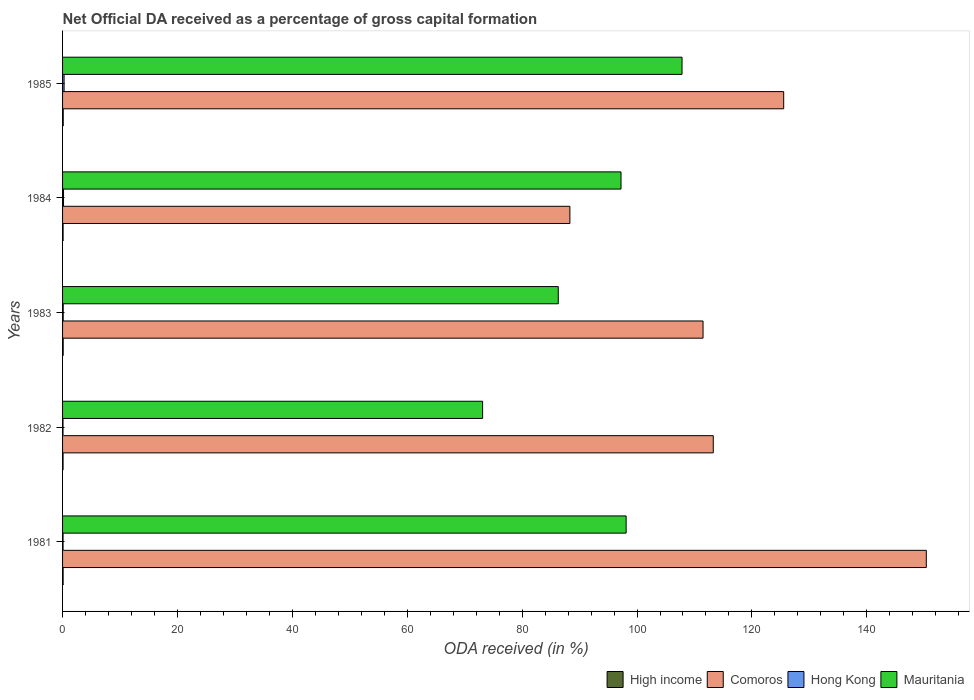How many groups of bars are there?
Provide a succinct answer. 5. Are the number of bars on each tick of the Y-axis equal?
Provide a succinct answer. Yes. What is the label of the 1st group of bars from the top?
Ensure brevity in your answer.  1985. What is the net ODA received in Comoros in 1981?
Offer a terse response. 150.36. Across all years, what is the maximum net ODA received in Mauritania?
Your answer should be compact. 107.84. Across all years, what is the minimum net ODA received in High income?
Ensure brevity in your answer.  0.09. In which year was the net ODA received in Comoros minimum?
Offer a terse response. 1984. What is the total net ODA received in Hong Kong in the graph?
Offer a very short reply. 0.71. What is the difference between the net ODA received in Hong Kong in 1981 and that in 1983?
Your answer should be very brief. -0.02. What is the difference between the net ODA received in Mauritania in 1985 and the net ODA received in Comoros in 1984?
Give a very brief answer. 19.52. What is the average net ODA received in Mauritania per year?
Offer a terse response. 92.51. In the year 1984, what is the difference between the net ODA received in Hong Kong and net ODA received in Comoros?
Provide a succinct answer. -88.15. In how many years, is the net ODA received in Mauritania greater than 116 %?
Give a very brief answer. 0. What is the ratio of the net ODA received in Comoros in 1982 to that in 1983?
Make the answer very short. 1.02. Is the difference between the net ODA received in Hong Kong in 1981 and 1985 greater than the difference between the net ODA received in Comoros in 1981 and 1985?
Ensure brevity in your answer.  No. What is the difference between the highest and the second highest net ODA received in Comoros?
Make the answer very short. 24.83. What is the difference between the highest and the lowest net ODA received in Mauritania?
Your response must be concise. 34.72. In how many years, is the net ODA received in Hong Kong greater than the average net ODA received in Hong Kong taken over all years?
Your response must be concise. 2. Is the sum of the net ODA received in Hong Kong in 1984 and 1985 greater than the maximum net ODA received in Comoros across all years?
Give a very brief answer. No. Is it the case that in every year, the sum of the net ODA received in Mauritania and net ODA received in High income is greater than the sum of net ODA received in Comoros and net ODA received in Hong Kong?
Your answer should be compact. No. What does the 3rd bar from the top in 1985 represents?
Your answer should be very brief. Comoros. What does the 4th bar from the bottom in 1984 represents?
Ensure brevity in your answer.  Mauritania. Is it the case that in every year, the sum of the net ODA received in High income and net ODA received in Hong Kong is greater than the net ODA received in Mauritania?
Offer a very short reply. No. Are all the bars in the graph horizontal?
Offer a terse response. Yes. What is the difference between two consecutive major ticks on the X-axis?
Make the answer very short. 20. Where does the legend appear in the graph?
Keep it short and to the point. Bottom right. What is the title of the graph?
Keep it short and to the point. Net Official DA received as a percentage of gross capital formation. What is the label or title of the X-axis?
Your answer should be very brief. ODA received (in %). What is the ODA received (in %) in High income in 1981?
Make the answer very short. 0.1. What is the ODA received (in %) of Comoros in 1981?
Keep it short and to the point. 150.36. What is the ODA received (in %) of Hong Kong in 1981?
Keep it short and to the point. 0.09. What is the ODA received (in %) in Mauritania in 1981?
Offer a terse response. 98.11. What is the ODA received (in %) of High income in 1982?
Your response must be concise. 0.09. What is the ODA received (in %) in Comoros in 1982?
Provide a short and direct response. 113.27. What is the ODA received (in %) in Hong Kong in 1982?
Provide a short and direct response. 0.08. What is the ODA received (in %) in Mauritania in 1982?
Keep it short and to the point. 73.12. What is the ODA received (in %) of High income in 1983?
Give a very brief answer. 0.11. What is the ODA received (in %) in Comoros in 1983?
Give a very brief answer. 111.5. What is the ODA received (in %) of Hong Kong in 1983?
Keep it short and to the point. 0.11. What is the ODA received (in %) in Mauritania in 1983?
Make the answer very short. 86.29. What is the ODA received (in %) in High income in 1984?
Keep it short and to the point. 0.09. What is the ODA received (in %) in Comoros in 1984?
Your answer should be very brief. 88.31. What is the ODA received (in %) in Hong Kong in 1984?
Your answer should be very brief. 0.17. What is the ODA received (in %) in Mauritania in 1984?
Your response must be concise. 97.21. What is the ODA received (in %) of High income in 1985?
Provide a succinct answer. 0.11. What is the ODA received (in %) of Comoros in 1985?
Provide a succinct answer. 125.53. What is the ODA received (in %) in Hong Kong in 1985?
Your answer should be compact. 0.27. What is the ODA received (in %) in Mauritania in 1985?
Your response must be concise. 107.84. Across all years, what is the maximum ODA received (in %) in High income?
Offer a terse response. 0.11. Across all years, what is the maximum ODA received (in %) in Comoros?
Ensure brevity in your answer.  150.36. Across all years, what is the maximum ODA received (in %) of Hong Kong?
Make the answer very short. 0.27. Across all years, what is the maximum ODA received (in %) of Mauritania?
Give a very brief answer. 107.84. Across all years, what is the minimum ODA received (in %) in High income?
Offer a terse response. 0.09. Across all years, what is the minimum ODA received (in %) of Comoros?
Your response must be concise. 88.31. Across all years, what is the minimum ODA received (in %) in Hong Kong?
Your response must be concise. 0.08. Across all years, what is the minimum ODA received (in %) of Mauritania?
Give a very brief answer. 73.12. What is the total ODA received (in %) of High income in the graph?
Your answer should be very brief. 0.5. What is the total ODA received (in %) of Comoros in the graph?
Offer a very short reply. 588.97. What is the total ODA received (in %) of Hong Kong in the graph?
Provide a short and direct response. 0.71. What is the total ODA received (in %) in Mauritania in the graph?
Give a very brief answer. 462.57. What is the difference between the ODA received (in %) of High income in 1981 and that in 1982?
Give a very brief answer. 0.01. What is the difference between the ODA received (in %) of Comoros in 1981 and that in 1982?
Your answer should be very brief. 37.09. What is the difference between the ODA received (in %) of Hong Kong in 1981 and that in 1982?
Offer a very short reply. 0.01. What is the difference between the ODA received (in %) of Mauritania in 1981 and that in 1982?
Your response must be concise. 24.98. What is the difference between the ODA received (in %) of High income in 1981 and that in 1983?
Keep it short and to the point. -0.01. What is the difference between the ODA received (in %) of Comoros in 1981 and that in 1983?
Ensure brevity in your answer.  38.86. What is the difference between the ODA received (in %) in Hong Kong in 1981 and that in 1983?
Provide a succinct answer. -0.02. What is the difference between the ODA received (in %) in Mauritania in 1981 and that in 1983?
Your response must be concise. 11.82. What is the difference between the ODA received (in %) in High income in 1981 and that in 1984?
Keep it short and to the point. 0. What is the difference between the ODA received (in %) of Comoros in 1981 and that in 1984?
Your answer should be compact. 62.05. What is the difference between the ODA received (in %) in Hong Kong in 1981 and that in 1984?
Your response must be concise. -0.08. What is the difference between the ODA received (in %) in Mauritania in 1981 and that in 1984?
Your answer should be compact. 0.89. What is the difference between the ODA received (in %) of High income in 1981 and that in 1985?
Provide a short and direct response. -0.02. What is the difference between the ODA received (in %) of Comoros in 1981 and that in 1985?
Your answer should be very brief. 24.83. What is the difference between the ODA received (in %) of Hong Kong in 1981 and that in 1985?
Ensure brevity in your answer.  -0.18. What is the difference between the ODA received (in %) of Mauritania in 1981 and that in 1985?
Provide a succinct answer. -9.73. What is the difference between the ODA received (in %) in High income in 1982 and that in 1983?
Offer a very short reply. -0.02. What is the difference between the ODA received (in %) of Comoros in 1982 and that in 1983?
Your answer should be very brief. 1.78. What is the difference between the ODA received (in %) in Hong Kong in 1982 and that in 1983?
Offer a terse response. -0.03. What is the difference between the ODA received (in %) of Mauritania in 1982 and that in 1983?
Offer a very short reply. -13.17. What is the difference between the ODA received (in %) in High income in 1982 and that in 1984?
Ensure brevity in your answer.  -0.01. What is the difference between the ODA received (in %) in Comoros in 1982 and that in 1984?
Keep it short and to the point. 24.96. What is the difference between the ODA received (in %) of Hong Kong in 1982 and that in 1984?
Your answer should be compact. -0.09. What is the difference between the ODA received (in %) of Mauritania in 1982 and that in 1984?
Keep it short and to the point. -24.09. What is the difference between the ODA received (in %) of High income in 1982 and that in 1985?
Your answer should be compact. -0.03. What is the difference between the ODA received (in %) of Comoros in 1982 and that in 1985?
Make the answer very short. -12.26. What is the difference between the ODA received (in %) of Hong Kong in 1982 and that in 1985?
Your answer should be very brief. -0.19. What is the difference between the ODA received (in %) of Mauritania in 1982 and that in 1985?
Ensure brevity in your answer.  -34.72. What is the difference between the ODA received (in %) in High income in 1983 and that in 1984?
Your answer should be very brief. 0.02. What is the difference between the ODA received (in %) in Comoros in 1983 and that in 1984?
Your response must be concise. 23.18. What is the difference between the ODA received (in %) of Hong Kong in 1983 and that in 1984?
Provide a short and direct response. -0.06. What is the difference between the ODA received (in %) of Mauritania in 1983 and that in 1984?
Offer a terse response. -10.92. What is the difference between the ODA received (in %) of High income in 1983 and that in 1985?
Keep it short and to the point. -0.01. What is the difference between the ODA received (in %) of Comoros in 1983 and that in 1985?
Give a very brief answer. -14.04. What is the difference between the ODA received (in %) of Hong Kong in 1983 and that in 1985?
Keep it short and to the point. -0.16. What is the difference between the ODA received (in %) of Mauritania in 1983 and that in 1985?
Your answer should be compact. -21.55. What is the difference between the ODA received (in %) of High income in 1984 and that in 1985?
Offer a terse response. -0.02. What is the difference between the ODA received (in %) of Comoros in 1984 and that in 1985?
Your answer should be very brief. -37.22. What is the difference between the ODA received (in %) of Hong Kong in 1984 and that in 1985?
Your answer should be very brief. -0.1. What is the difference between the ODA received (in %) in Mauritania in 1984 and that in 1985?
Give a very brief answer. -10.62. What is the difference between the ODA received (in %) in High income in 1981 and the ODA received (in %) in Comoros in 1982?
Keep it short and to the point. -113.18. What is the difference between the ODA received (in %) of High income in 1981 and the ODA received (in %) of Hong Kong in 1982?
Ensure brevity in your answer.  0.02. What is the difference between the ODA received (in %) in High income in 1981 and the ODA received (in %) in Mauritania in 1982?
Your answer should be very brief. -73.03. What is the difference between the ODA received (in %) in Comoros in 1981 and the ODA received (in %) in Hong Kong in 1982?
Offer a terse response. 150.28. What is the difference between the ODA received (in %) of Comoros in 1981 and the ODA received (in %) of Mauritania in 1982?
Your response must be concise. 77.24. What is the difference between the ODA received (in %) of Hong Kong in 1981 and the ODA received (in %) of Mauritania in 1982?
Offer a terse response. -73.03. What is the difference between the ODA received (in %) of High income in 1981 and the ODA received (in %) of Comoros in 1983?
Your answer should be very brief. -111.4. What is the difference between the ODA received (in %) in High income in 1981 and the ODA received (in %) in Hong Kong in 1983?
Your answer should be very brief. -0.01. What is the difference between the ODA received (in %) in High income in 1981 and the ODA received (in %) in Mauritania in 1983?
Your answer should be very brief. -86.19. What is the difference between the ODA received (in %) of Comoros in 1981 and the ODA received (in %) of Hong Kong in 1983?
Your answer should be very brief. 150.25. What is the difference between the ODA received (in %) of Comoros in 1981 and the ODA received (in %) of Mauritania in 1983?
Your answer should be very brief. 64.07. What is the difference between the ODA received (in %) of Hong Kong in 1981 and the ODA received (in %) of Mauritania in 1983?
Provide a short and direct response. -86.2. What is the difference between the ODA received (in %) of High income in 1981 and the ODA received (in %) of Comoros in 1984?
Your answer should be compact. -88.22. What is the difference between the ODA received (in %) in High income in 1981 and the ODA received (in %) in Hong Kong in 1984?
Your answer should be compact. -0.07. What is the difference between the ODA received (in %) of High income in 1981 and the ODA received (in %) of Mauritania in 1984?
Your answer should be very brief. -97.12. What is the difference between the ODA received (in %) in Comoros in 1981 and the ODA received (in %) in Hong Kong in 1984?
Provide a short and direct response. 150.19. What is the difference between the ODA received (in %) of Comoros in 1981 and the ODA received (in %) of Mauritania in 1984?
Your answer should be very brief. 53.14. What is the difference between the ODA received (in %) of Hong Kong in 1981 and the ODA received (in %) of Mauritania in 1984?
Your answer should be very brief. -97.13. What is the difference between the ODA received (in %) of High income in 1981 and the ODA received (in %) of Comoros in 1985?
Provide a succinct answer. -125.44. What is the difference between the ODA received (in %) in High income in 1981 and the ODA received (in %) in Hong Kong in 1985?
Give a very brief answer. -0.17. What is the difference between the ODA received (in %) in High income in 1981 and the ODA received (in %) in Mauritania in 1985?
Ensure brevity in your answer.  -107.74. What is the difference between the ODA received (in %) of Comoros in 1981 and the ODA received (in %) of Hong Kong in 1985?
Keep it short and to the point. 150.09. What is the difference between the ODA received (in %) in Comoros in 1981 and the ODA received (in %) in Mauritania in 1985?
Make the answer very short. 42.52. What is the difference between the ODA received (in %) of Hong Kong in 1981 and the ODA received (in %) of Mauritania in 1985?
Give a very brief answer. -107.75. What is the difference between the ODA received (in %) of High income in 1982 and the ODA received (in %) of Comoros in 1983?
Your response must be concise. -111.41. What is the difference between the ODA received (in %) in High income in 1982 and the ODA received (in %) in Hong Kong in 1983?
Provide a short and direct response. -0.02. What is the difference between the ODA received (in %) in High income in 1982 and the ODA received (in %) in Mauritania in 1983?
Your answer should be compact. -86.2. What is the difference between the ODA received (in %) of Comoros in 1982 and the ODA received (in %) of Hong Kong in 1983?
Keep it short and to the point. 113.16. What is the difference between the ODA received (in %) in Comoros in 1982 and the ODA received (in %) in Mauritania in 1983?
Your answer should be compact. 26.98. What is the difference between the ODA received (in %) in Hong Kong in 1982 and the ODA received (in %) in Mauritania in 1983?
Offer a terse response. -86.21. What is the difference between the ODA received (in %) in High income in 1982 and the ODA received (in %) in Comoros in 1984?
Your answer should be compact. -88.23. What is the difference between the ODA received (in %) of High income in 1982 and the ODA received (in %) of Hong Kong in 1984?
Provide a succinct answer. -0.08. What is the difference between the ODA received (in %) of High income in 1982 and the ODA received (in %) of Mauritania in 1984?
Provide a short and direct response. -97.13. What is the difference between the ODA received (in %) of Comoros in 1982 and the ODA received (in %) of Hong Kong in 1984?
Your answer should be very brief. 113.11. What is the difference between the ODA received (in %) of Comoros in 1982 and the ODA received (in %) of Mauritania in 1984?
Your response must be concise. 16.06. What is the difference between the ODA received (in %) of Hong Kong in 1982 and the ODA received (in %) of Mauritania in 1984?
Your response must be concise. -97.14. What is the difference between the ODA received (in %) of High income in 1982 and the ODA received (in %) of Comoros in 1985?
Your answer should be very brief. -125.45. What is the difference between the ODA received (in %) of High income in 1982 and the ODA received (in %) of Hong Kong in 1985?
Your answer should be compact. -0.18. What is the difference between the ODA received (in %) in High income in 1982 and the ODA received (in %) in Mauritania in 1985?
Your answer should be very brief. -107.75. What is the difference between the ODA received (in %) in Comoros in 1982 and the ODA received (in %) in Hong Kong in 1985?
Your response must be concise. 113.01. What is the difference between the ODA received (in %) of Comoros in 1982 and the ODA received (in %) of Mauritania in 1985?
Your response must be concise. 5.44. What is the difference between the ODA received (in %) in Hong Kong in 1982 and the ODA received (in %) in Mauritania in 1985?
Offer a terse response. -107.76. What is the difference between the ODA received (in %) of High income in 1983 and the ODA received (in %) of Comoros in 1984?
Your response must be concise. -88.2. What is the difference between the ODA received (in %) in High income in 1983 and the ODA received (in %) in Hong Kong in 1984?
Keep it short and to the point. -0.06. What is the difference between the ODA received (in %) in High income in 1983 and the ODA received (in %) in Mauritania in 1984?
Provide a short and direct response. -97.11. What is the difference between the ODA received (in %) in Comoros in 1983 and the ODA received (in %) in Hong Kong in 1984?
Provide a short and direct response. 111.33. What is the difference between the ODA received (in %) of Comoros in 1983 and the ODA received (in %) of Mauritania in 1984?
Provide a succinct answer. 14.28. What is the difference between the ODA received (in %) in Hong Kong in 1983 and the ODA received (in %) in Mauritania in 1984?
Give a very brief answer. -97.1. What is the difference between the ODA received (in %) in High income in 1983 and the ODA received (in %) in Comoros in 1985?
Keep it short and to the point. -125.42. What is the difference between the ODA received (in %) in High income in 1983 and the ODA received (in %) in Hong Kong in 1985?
Give a very brief answer. -0.16. What is the difference between the ODA received (in %) of High income in 1983 and the ODA received (in %) of Mauritania in 1985?
Ensure brevity in your answer.  -107.73. What is the difference between the ODA received (in %) of Comoros in 1983 and the ODA received (in %) of Hong Kong in 1985?
Your answer should be very brief. 111.23. What is the difference between the ODA received (in %) of Comoros in 1983 and the ODA received (in %) of Mauritania in 1985?
Provide a short and direct response. 3.66. What is the difference between the ODA received (in %) of Hong Kong in 1983 and the ODA received (in %) of Mauritania in 1985?
Your answer should be compact. -107.73. What is the difference between the ODA received (in %) in High income in 1984 and the ODA received (in %) in Comoros in 1985?
Your response must be concise. -125.44. What is the difference between the ODA received (in %) of High income in 1984 and the ODA received (in %) of Hong Kong in 1985?
Your response must be concise. -0.17. What is the difference between the ODA received (in %) of High income in 1984 and the ODA received (in %) of Mauritania in 1985?
Keep it short and to the point. -107.74. What is the difference between the ODA received (in %) of Comoros in 1984 and the ODA received (in %) of Hong Kong in 1985?
Provide a succinct answer. 88.05. What is the difference between the ODA received (in %) of Comoros in 1984 and the ODA received (in %) of Mauritania in 1985?
Keep it short and to the point. -19.52. What is the difference between the ODA received (in %) in Hong Kong in 1984 and the ODA received (in %) in Mauritania in 1985?
Your answer should be very brief. -107.67. What is the average ODA received (in %) of High income per year?
Make the answer very short. 0.1. What is the average ODA received (in %) of Comoros per year?
Give a very brief answer. 117.79. What is the average ODA received (in %) in Hong Kong per year?
Give a very brief answer. 0.14. What is the average ODA received (in %) of Mauritania per year?
Keep it short and to the point. 92.51. In the year 1981, what is the difference between the ODA received (in %) of High income and ODA received (in %) of Comoros?
Give a very brief answer. -150.26. In the year 1981, what is the difference between the ODA received (in %) of High income and ODA received (in %) of Hong Kong?
Your response must be concise. 0.01. In the year 1981, what is the difference between the ODA received (in %) of High income and ODA received (in %) of Mauritania?
Offer a very short reply. -98.01. In the year 1981, what is the difference between the ODA received (in %) of Comoros and ODA received (in %) of Hong Kong?
Provide a succinct answer. 150.27. In the year 1981, what is the difference between the ODA received (in %) in Comoros and ODA received (in %) in Mauritania?
Offer a terse response. 52.25. In the year 1981, what is the difference between the ODA received (in %) of Hong Kong and ODA received (in %) of Mauritania?
Ensure brevity in your answer.  -98.02. In the year 1982, what is the difference between the ODA received (in %) in High income and ODA received (in %) in Comoros?
Ensure brevity in your answer.  -113.19. In the year 1982, what is the difference between the ODA received (in %) in High income and ODA received (in %) in Hong Kong?
Provide a succinct answer. 0.01. In the year 1982, what is the difference between the ODA received (in %) in High income and ODA received (in %) in Mauritania?
Make the answer very short. -73.03. In the year 1982, what is the difference between the ODA received (in %) of Comoros and ODA received (in %) of Hong Kong?
Offer a very short reply. 113.19. In the year 1982, what is the difference between the ODA received (in %) of Comoros and ODA received (in %) of Mauritania?
Your response must be concise. 40.15. In the year 1982, what is the difference between the ODA received (in %) of Hong Kong and ODA received (in %) of Mauritania?
Provide a succinct answer. -73.04. In the year 1983, what is the difference between the ODA received (in %) in High income and ODA received (in %) in Comoros?
Your response must be concise. -111.39. In the year 1983, what is the difference between the ODA received (in %) in High income and ODA received (in %) in Hong Kong?
Offer a very short reply. -0. In the year 1983, what is the difference between the ODA received (in %) in High income and ODA received (in %) in Mauritania?
Provide a short and direct response. -86.18. In the year 1983, what is the difference between the ODA received (in %) in Comoros and ODA received (in %) in Hong Kong?
Give a very brief answer. 111.39. In the year 1983, what is the difference between the ODA received (in %) in Comoros and ODA received (in %) in Mauritania?
Provide a short and direct response. 25.2. In the year 1983, what is the difference between the ODA received (in %) of Hong Kong and ODA received (in %) of Mauritania?
Ensure brevity in your answer.  -86.18. In the year 1984, what is the difference between the ODA received (in %) in High income and ODA received (in %) in Comoros?
Ensure brevity in your answer.  -88.22. In the year 1984, what is the difference between the ODA received (in %) of High income and ODA received (in %) of Hong Kong?
Provide a short and direct response. -0.08. In the year 1984, what is the difference between the ODA received (in %) in High income and ODA received (in %) in Mauritania?
Your response must be concise. -97.12. In the year 1984, what is the difference between the ODA received (in %) in Comoros and ODA received (in %) in Hong Kong?
Provide a succinct answer. 88.15. In the year 1984, what is the difference between the ODA received (in %) in Comoros and ODA received (in %) in Mauritania?
Give a very brief answer. -8.9. In the year 1984, what is the difference between the ODA received (in %) of Hong Kong and ODA received (in %) of Mauritania?
Keep it short and to the point. -97.05. In the year 1985, what is the difference between the ODA received (in %) of High income and ODA received (in %) of Comoros?
Keep it short and to the point. -125.42. In the year 1985, what is the difference between the ODA received (in %) in High income and ODA received (in %) in Hong Kong?
Ensure brevity in your answer.  -0.15. In the year 1985, what is the difference between the ODA received (in %) in High income and ODA received (in %) in Mauritania?
Keep it short and to the point. -107.72. In the year 1985, what is the difference between the ODA received (in %) of Comoros and ODA received (in %) of Hong Kong?
Ensure brevity in your answer.  125.27. In the year 1985, what is the difference between the ODA received (in %) in Comoros and ODA received (in %) in Mauritania?
Provide a succinct answer. 17.7. In the year 1985, what is the difference between the ODA received (in %) of Hong Kong and ODA received (in %) of Mauritania?
Make the answer very short. -107.57. What is the ratio of the ODA received (in %) of High income in 1981 to that in 1982?
Keep it short and to the point. 1.11. What is the ratio of the ODA received (in %) in Comoros in 1981 to that in 1982?
Make the answer very short. 1.33. What is the ratio of the ODA received (in %) of Hong Kong in 1981 to that in 1982?
Make the answer very short. 1.11. What is the ratio of the ODA received (in %) of Mauritania in 1981 to that in 1982?
Your answer should be very brief. 1.34. What is the ratio of the ODA received (in %) in High income in 1981 to that in 1983?
Keep it short and to the point. 0.89. What is the ratio of the ODA received (in %) in Comoros in 1981 to that in 1983?
Provide a succinct answer. 1.35. What is the ratio of the ODA received (in %) in Hong Kong in 1981 to that in 1983?
Make the answer very short. 0.8. What is the ratio of the ODA received (in %) of Mauritania in 1981 to that in 1983?
Make the answer very short. 1.14. What is the ratio of the ODA received (in %) in High income in 1981 to that in 1984?
Make the answer very short. 1.05. What is the ratio of the ODA received (in %) in Comoros in 1981 to that in 1984?
Your answer should be compact. 1.7. What is the ratio of the ODA received (in %) in Hong Kong in 1981 to that in 1984?
Provide a short and direct response. 0.52. What is the ratio of the ODA received (in %) of Mauritania in 1981 to that in 1984?
Give a very brief answer. 1.01. What is the ratio of the ODA received (in %) of High income in 1981 to that in 1985?
Ensure brevity in your answer.  0.85. What is the ratio of the ODA received (in %) in Comoros in 1981 to that in 1985?
Provide a succinct answer. 1.2. What is the ratio of the ODA received (in %) in Hong Kong in 1981 to that in 1985?
Your response must be concise. 0.33. What is the ratio of the ODA received (in %) in Mauritania in 1981 to that in 1985?
Provide a succinct answer. 0.91. What is the ratio of the ODA received (in %) of High income in 1982 to that in 1983?
Offer a very short reply. 0.8. What is the ratio of the ODA received (in %) of Comoros in 1982 to that in 1983?
Offer a very short reply. 1.02. What is the ratio of the ODA received (in %) of Hong Kong in 1982 to that in 1983?
Provide a succinct answer. 0.72. What is the ratio of the ODA received (in %) of Mauritania in 1982 to that in 1983?
Provide a succinct answer. 0.85. What is the ratio of the ODA received (in %) of High income in 1982 to that in 1984?
Give a very brief answer. 0.94. What is the ratio of the ODA received (in %) of Comoros in 1982 to that in 1984?
Provide a short and direct response. 1.28. What is the ratio of the ODA received (in %) in Hong Kong in 1982 to that in 1984?
Ensure brevity in your answer.  0.47. What is the ratio of the ODA received (in %) of Mauritania in 1982 to that in 1984?
Make the answer very short. 0.75. What is the ratio of the ODA received (in %) of High income in 1982 to that in 1985?
Provide a succinct answer. 0.76. What is the ratio of the ODA received (in %) in Comoros in 1982 to that in 1985?
Offer a terse response. 0.9. What is the ratio of the ODA received (in %) of Hong Kong in 1982 to that in 1985?
Your answer should be very brief. 0.3. What is the ratio of the ODA received (in %) of Mauritania in 1982 to that in 1985?
Keep it short and to the point. 0.68. What is the ratio of the ODA received (in %) in High income in 1983 to that in 1984?
Your response must be concise. 1.18. What is the ratio of the ODA received (in %) of Comoros in 1983 to that in 1984?
Your answer should be compact. 1.26. What is the ratio of the ODA received (in %) in Hong Kong in 1983 to that in 1984?
Your answer should be very brief. 0.66. What is the ratio of the ODA received (in %) in Mauritania in 1983 to that in 1984?
Give a very brief answer. 0.89. What is the ratio of the ODA received (in %) in High income in 1983 to that in 1985?
Your answer should be very brief. 0.96. What is the ratio of the ODA received (in %) in Comoros in 1983 to that in 1985?
Offer a terse response. 0.89. What is the ratio of the ODA received (in %) in Hong Kong in 1983 to that in 1985?
Provide a short and direct response. 0.41. What is the ratio of the ODA received (in %) of Mauritania in 1983 to that in 1985?
Provide a short and direct response. 0.8. What is the ratio of the ODA received (in %) of High income in 1984 to that in 1985?
Make the answer very short. 0.81. What is the ratio of the ODA received (in %) in Comoros in 1984 to that in 1985?
Ensure brevity in your answer.  0.7. What is the ratio of the ODA received (in %) in Hong Kong in 1984 to that in 1985?
Ensure brevity in your answer.  0.63. What is the ratio of the ODA received (in %) in Mauritania in 1984 to that in 1985?
Your answer should be compact. 0.9. What is the difference between the highest and the second highest ODA received (in %) in High income?
Provide a succinct answer. 0.01. What is the difference between the highest and the second highest ODA received (in %) of Comoros?
Your answer should be compact. 24.83. What is the difference between the highest and the second highest ODA received (in %) of Hong Kong?
Your response must be concise. 0.1. What is the difference between the highest and the second highest ODA received (in %) in Mauritania?
Provide a succinct answer. 9.73. What is the difference between the highest and the lowest ODA received (in %) in High income?
Make the answer very short. 0.03. What is the difference between the highest and the lowest ODA received (in %) in Comoros?
Your response must be concise. 62.05. What is the difference between the highest and the lowest ODA received (in %) in Hong Kong?
Make the answer very short. 0.19. What is the difference between the highest and the lowest ODA received (in %) of Mauritania?
Provide a succinct answer. 34.72. 